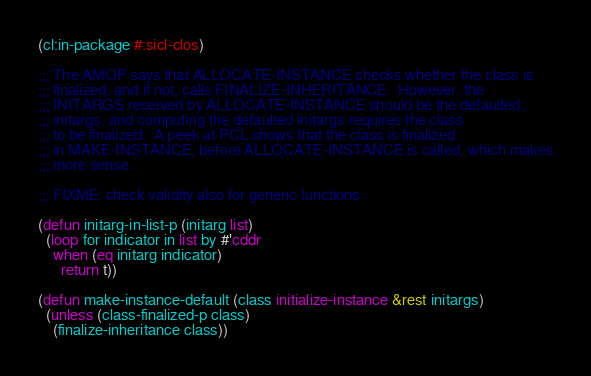Convert code to text. <code><loc_0><loc_0><loc_500><loc_500><_Lisp_>(cl:in-package #:sicl-clos)

;;; The AMOP says that ALLOCATE-INSTANCE checks whether the class is
;;; finalized, and if not, calls FINALIZE-INHERITANCE.  However, the
;;; INITARGS received by ALLOCATE-INSTANCE should be the defaulted
;;; initargs, and computing the defaulted initargs requires the class
;;; to be finalized.  A peek at PCL shows that the class is finalized
;;; in MAKE-INSTANCE, before ALLOCATE-INSTANCE is called, which makes
;;; more sense.

;;; FIXME: check validity also for generic functions

(defun initarg-in-list-p (initarg list)
  (loop for indicator in list by #'cddr
	when (eq initarg indicator)
	  return t))

(defun make-instance-default (class initialize-instance &rest initargs)
  (unless (class-finalized-p class)
    (finalize-inheritance class))</code> 